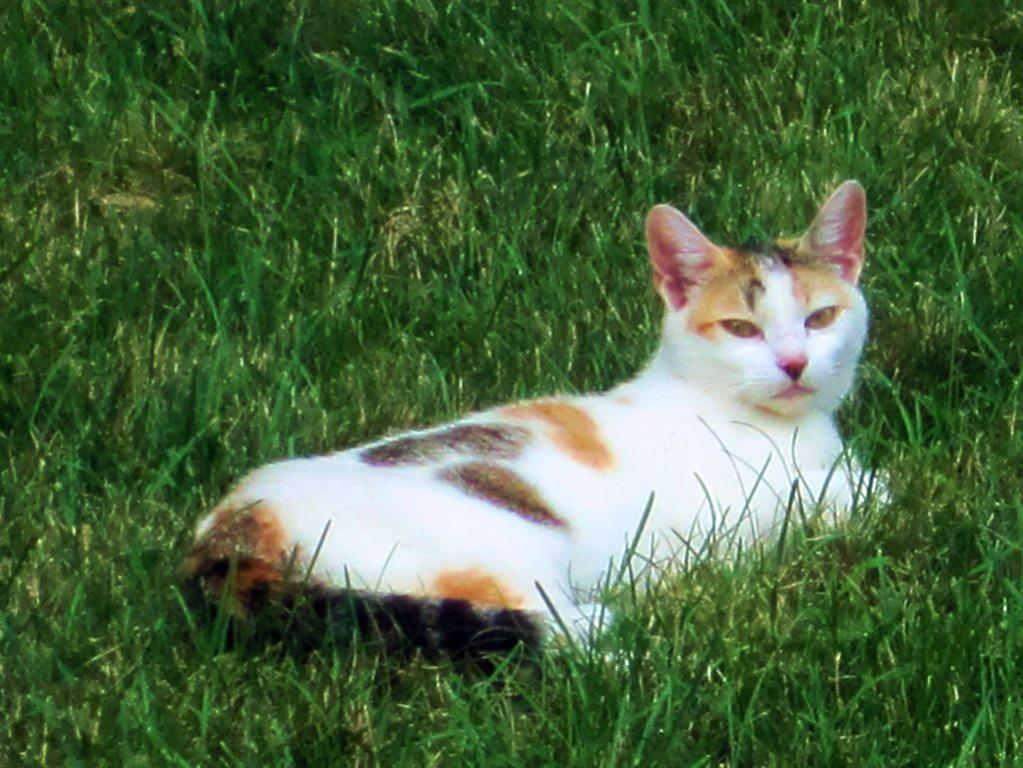What type of animal is in the image? There is a cat in the image. What type of vegetation can be seen in the image? There is grass visible in the image. What type of work is the cat doing in the image? The image does not depict the cat performing any work; it is simply present in the image. 